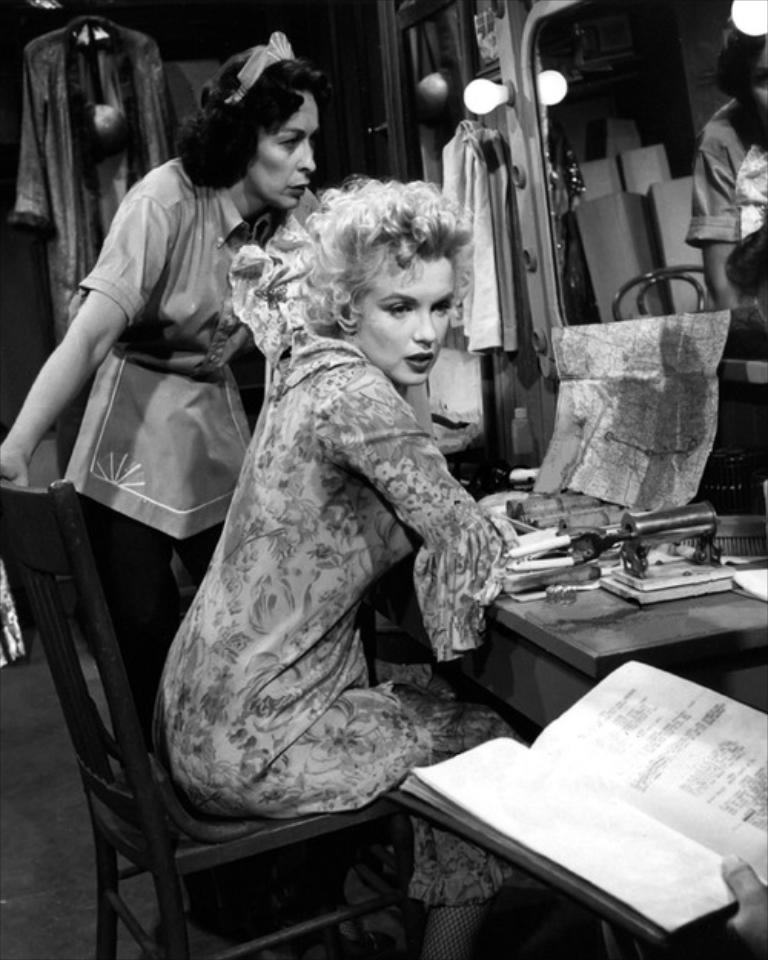Who is present in the image? There is a woman in the image. What is the woman doing in the image? The woman is sitting on a chair. What else can be seen in the image besides the woman? There is a table in the image. What is the woman standing on in the image? The woman is standing on the floor. What object related to reading or learning is present in the image? There is a book in the image. What can be seen providing illumination in the image? There are lights in the image. What type of comb is the woman using to fly the kite in the image? There is no comb or kite present in the image. 